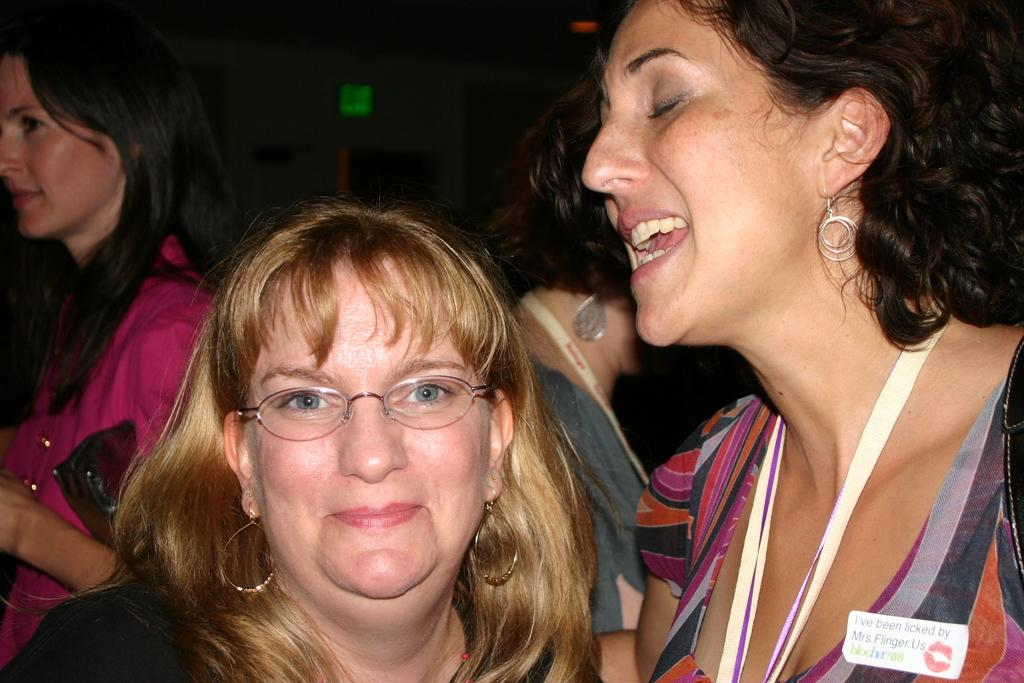What is happening in the image? There are people standing in the image. Can you describe any specific details about the people's clothing? There is a badge attached to a dress in the image. What can be seen on the badge? The badge appears to have tags. What is the color of the background in the image? The background of the image is dark. How deep is the root of the tree visible in the image? There is no tree visible in the image, only people standing and a badge with tags. Can you tell me how many items are in the pocket of the person on the left? There is no information about pockets or the number of items in the image. 